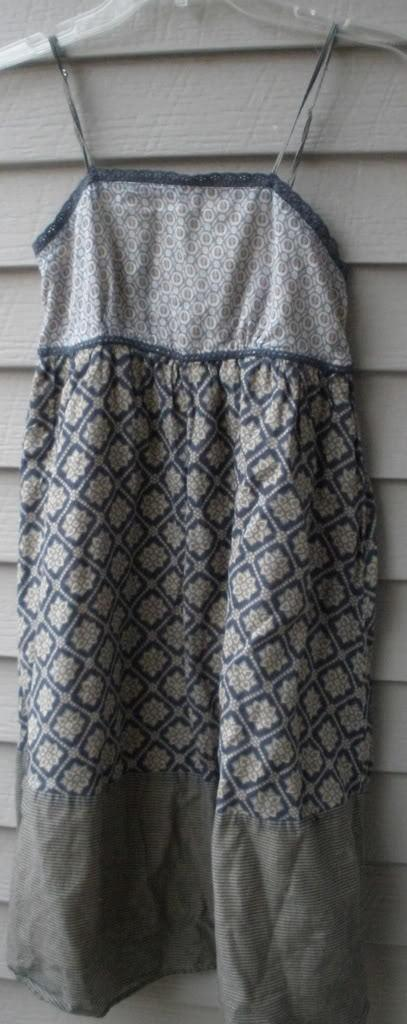What is hanging on something in the image? There is a dress hanging on a hanger in the image. Can you describe the setting where the dress is located? The image only shows a dress hanging on a hanger, so it is not possible to determine the setting. What type of hospital equipment can be seen in the image? There is no hospital equipment present in the image, as it features a dress hanging on a hanger. What type of slave labor is depicted in the image? There is no depiction of slave labor in the image, as it features a dress hanging on a hanger. What type of gun is visible in the image? There is no gun present in the image, as it features a dress hanging on a hanger. 